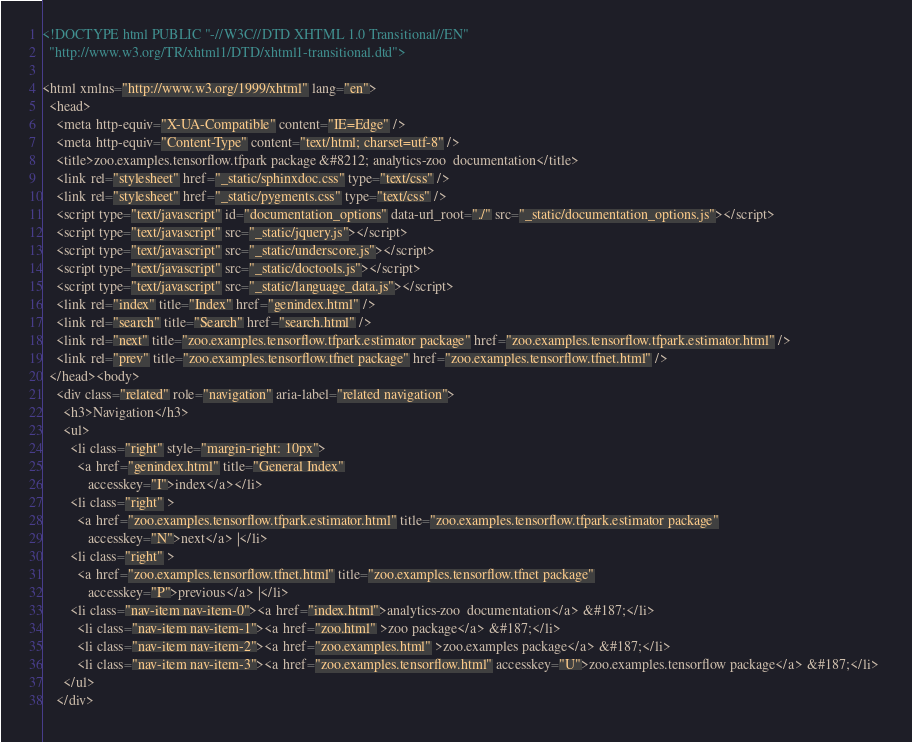<code> <loc_0><loc_0><loc_500><loc_500><_HTML_>
<!DOCTYPE html PUBLIC "-//W3C//DTD XHTML 1.0 Transitional//EN"
  "http://www.w3.org/TR/xhtml1/DTD/xhtml1-transitional.dtd">

<html xmlns="http://www.w3.org/1999/xhtml" lang="en">
  <head>
    <meta http-equiv="X-UA-Compatible" content="IE=Edge" />
    <meta http-equiv="Content-Type" content="text/html; charset=utf-8" />
    <title>zoo.examples.tensorflow.tfpark package &#8212; analytics-zoo  documentation</title>
    <link rel="stylesheet" href="_static/sphinxdoc.css" type="text/css" />
    <link rel="stylesheet" href="_static/pygments.css" type="text/css" />
    <script type="text/javascript" id="documentation_options" data-url_root="./" src="_static/documentation_options.js"></script>
    <script type="text/javascript" src="_static/jquery.js"></script>
    <script type="text/javascript" src="_static/underscore.js"></script>
    <script type="text/javascript" src="_static/doctools.js"></script>
    <script type="text/javascript" src="_static/language_data.js"></script>
    <link rel="index" title="Index" href="genindex.html" />
    <link rel="search" title="Search" href="search.html" />
    <link rel="next" title="zoo.examples.tensorflow.tfpark.estimator package" href="zoo.examples.tensorflow.tfpark.estimator.html" />
    <link rel="prev" title="zoo.examples.tensorflow.tfnet package" href="zoo.examples.tensorflow.tfnet.html" /> 
  </head><body>
    <div class="related" role="navigation" aria-label="related navigation">
      <h3>Navigation</h3>
      <ul>
        <li class="right" style="margin-right: 10px">
          <a href="genindex.html" title="General Index"
             accesskey="I">index</a></li>
        <li class="right" >
          <a href="zoo.examples.tensorflow.tfpark.estimator.html" title="zoo.examples.tensorflow.tfpark.estimator package"
             accesskey="N">next</a> |</li>
        <li class="right" >
          <a href="zoo.examples.tensorflow.tfnet.html" title="zoo.examples.tensorflow.tfnet package"
             accesskey="P">previous</a> |</li>
        <li class="nav-item nav-item-0"><a href="index.html">analytics-zoo  documentation</a> &#187;</li>
          <li class="nav-item nav-item-1"><a href="zoo.html" >zoo package</a> &#187;</li>
          <li class="nav-item nav-item-2"><a href="zoo.examples.html" >zoo.examples package</a> &#187;</li>
          <li class="nav-item nav-item-3"><a href="zoo.examples.tensorflow.html" accesskey="U">zoo.examples.tensorflow package</a> &#187;</li> 
      </ul>
    </div></code> 